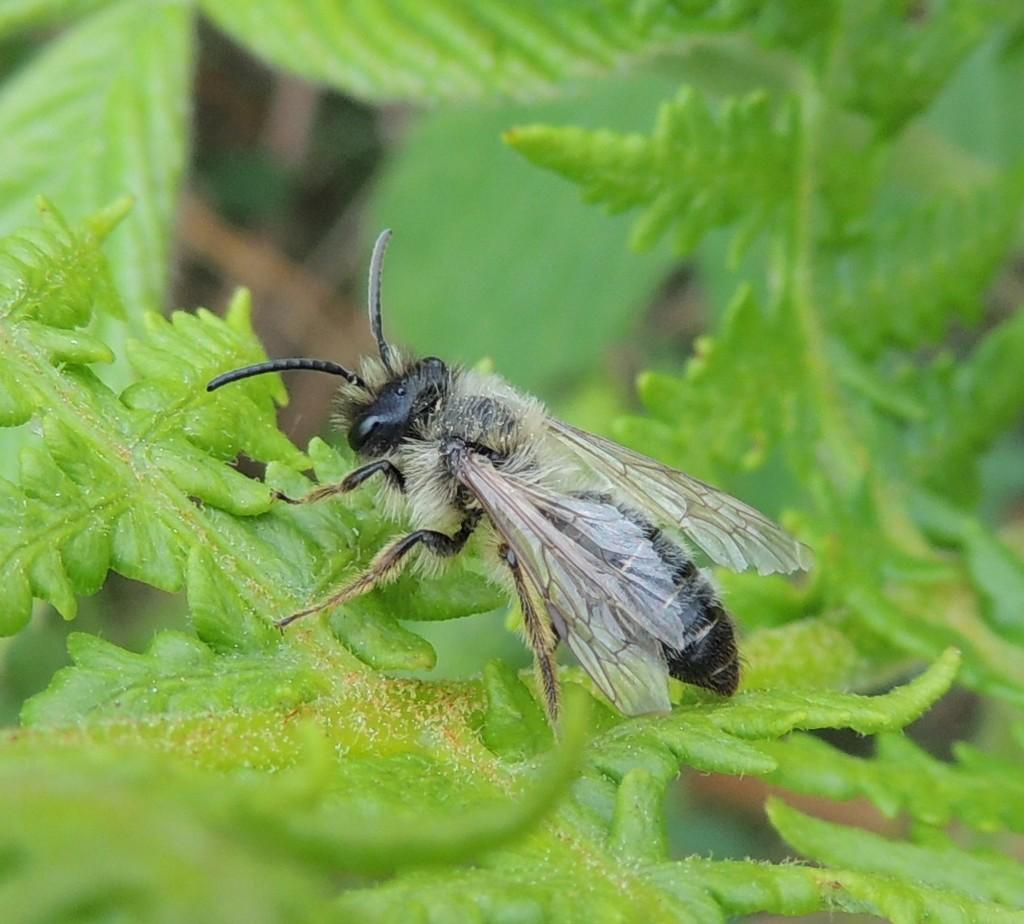What is the main subject of the picture? The main subject of the picture is a fly. Where is the fly located in the picture? The fly is on a leaf. What colors are visible on the fly? The fly is black and white in color. How many balls are visible in the picture? There are no balls present in the image; it features a fly on a leaf. What type of boundary is mentioned in the image? There is no mention of a boundary in the image, as it only features a fly on a leaf. 